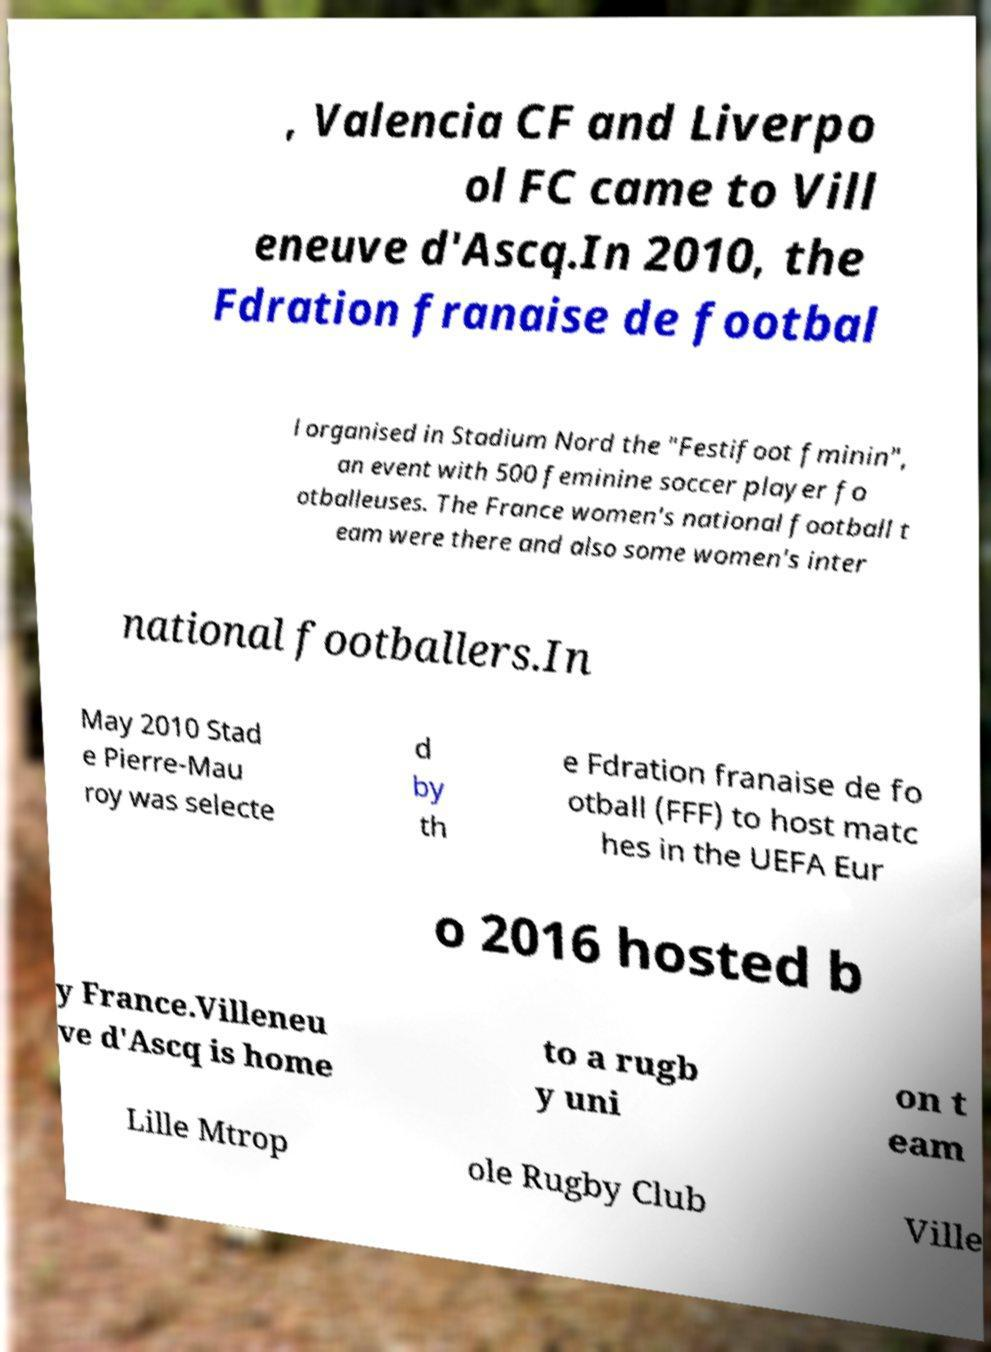Could you extract and type out the text from this image? , Valencia CF and Liverpo ol FC came to Vill eneuve d'Ascq.In 2010, the Fdration franaise de footbal l organised in Stadium Nord the "Festifoot fminin", an event with 500 feminine soccer player fo otballeuses. The France women's national football t eam were there and also some women's inter national footballers.In May 2010 Stad e Pierre-Mau roy was selecte d by th e Fdration franaise de fo otball (FFF) to host matc hes in the UEFA Eur o 2016 hosted b y France.Villeneu ve d'Ascq is home to a rugb y uni on t eam Lille Mtrop ole Rugby Club Ville 